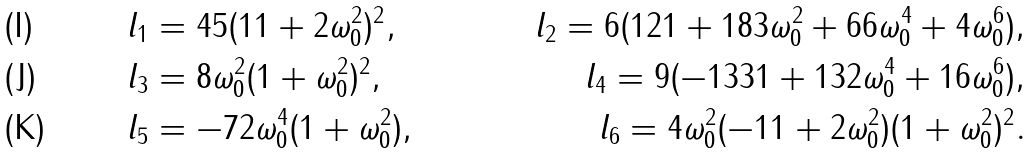<formula> <loc_0><loc_0><loc_500><loc_500>& l _ { 1 } = 4 5 ( 1 1 + 2 \omega _ { 0 } ^ { 2 } ) ^ { 2 } , & l _ { 2 } = 6 ( 1 2 1 + 1 8 3 \omega _ { 0 } ^ { 2 } + 6 6 \omega _ { 0 } ^ { 4 } + 4 \omega _ { 0 } ^ { 6 } ) , \\ & l _ { 3 } = 8 \omega _ { 0 } ^ { 2 } ( 1 + \omega _ { 0 } ^ { 2 } ) ^ { 2 } , & l _ { 4 } = 9 ( - 1 3 3 1 + 1 3 2 \omega _ { 0 } ^ { 4 } + 1 6 \omega _ { 0 } ^ { 6 } ) , \\ & l _ { 5 } = - 7 2 \omega _ { 0 } ^ { 4 } ( 1 + \omega _ { 0 } ^ { 2 } ) , & l _ { 6 } = 4 \omega _ { 0 } ^ { 2 } ( - 1 1 + 2 \omega _ { 0 } ^ { 2 } ) ( 1 + \omega _ { 0 } ^ { 2 } ) ^ { 2 } .</formula> 